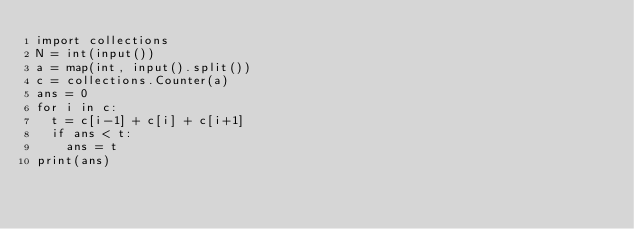<code> <loc_0><loc_0><loc_500><loc_500><_Python_>import collections
N = int(input())
a = map(int, input().split())
c = collections.Counter(a)
ans = 0
for i in c:
  t = c[i-1] + c[i] + c[i+1]
  if ans < t:
    ans = t
print(ans)</code> 